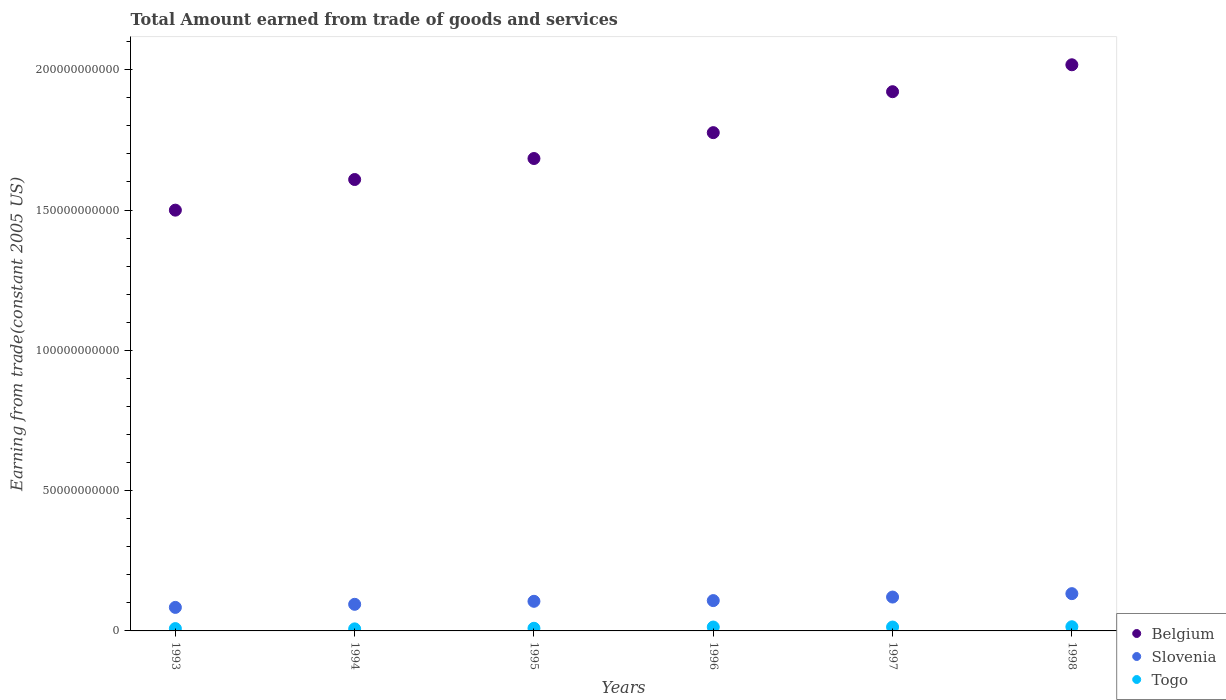What is the total amount earned by trading goods and services in Slovenia in 1996?
Your answer should be compact. 1.08e+1. Across all years, what is the maximum total amount earned by trading goods and services in Togo?
Provide a succinct answer. 1.49e+09. Across all years, what is the minimum total amount earned by trading goods and services in Belgium?
Offer a very short reply. 1.50e+11. What is the total total amount earned by trading goods and services in Togo in the graph?
Your response must be concise. 6.76e+09. What is the difference between the total amount earned by trading goods and services in Slovenia in 1993 and that in 1995?
Give a very brief answer. -2.17e+09. What is the difference between the total amount earned by trading goods and services in Slovenia in 1994 and the total amount earned by trading goods and services in Togo in 1996?
Offer a terse response. 8.10e+09. What is the average total amount earned by trading goods and services in Belgium per year?
Your answer should be very brief. 1.75e+11. In the year 1994, what is the difference between the total amount earned by trading goods and services in Belgium and total amount earned by trading goods and services in Slovenia?
Your answer should be very brief. 1.51e+11. In how many years, is the total amount earned by trading goods and services in Belgium greater than 100000000000 US$?
Offer a very short reply. 6. What is the ratio of the total amount earned by trading goods and services in Belgium in 1994 to that in 1997?
Your response must be concise. 0.84. Is the total amount earned by trading goods and services in Togo in 1996 less than that in 1998?
Your answer should be very brief. Yes. What is the difference between the highest and the second highest total amount earned by trading goods and services in Togo?
Your answer should be very brief. 1.02e+08. What is the difference between the highest and the lowest total amount earned by trading goods and services in Slovenia?
Your answer should be very brief. 4.90e+09. In how many years, is the total amount earned by trading goods and services in Togo greater than the average total amount earned by trading goods and services in Togo taken over all years?
Your response must be concise. 3. Is it the case that in every year, the sum of the total amount earned by trading goods and services in Slovenia and total amount earned by trading goods and services in Belgium  is greater than the total amount earned by trading goods and services in Togo?
Provide a succinct answer. Yes. Is the total amount earned by trading goods and services in Belgium strictly greater than the total amount earned by trading goods and services in Togo over the years?
Your response must be concise. Yes. How many years are there in the graph?
Your response must be concise. 6. What is the difference between two consecutive major ticks on the Y-axis?
Offer a very short reply. 5.00e+1. Are the values on the major ticks of Y-axis written in scientific E-notation?
Your answer should be compact. No. Does the graph contain any zero values?
Offer a terse response. No. Does the graph contain grids?
Make the answer very short. No. Where does the legend appear in the graph?
Ensure brevity in your answer.  Bottom right. How many legend labels are there?
Offer a terse response. 3. How are the legend labels stacked?
Ensure brevity in your answer.  Vertical. What is the title of the graph?
Offer a very short reply. Total Amount earned from trade of goods and services. What is the label or title of the X-axis?
Provide a short and direct response. Years. What is the label or title of the Y-axis?
Give a very brief answer. Earning from trade(constant 2005 US). What is the Earning from trade(constant 2005 US) in Belgium in 1993?
Your answer should be compact. 1.50e+11. What is the Earning from trade(constant 2005 US) in Slovenia in 1993?
Your answer should be compact. 8.38e+09. What is the Earning from trade(constant 2005 US) of Togo in 1993?
Offer a terse response. 8.31e+08. What is the Earning from trade(constant 2005 US) of Belgium in 1994?
Your answer should be very brief. 1.61e+11. What is the Earning from trade(constant 2005 US) of Slovenia in 1994?
Provide a succinct answer. 9.48e+09. What is the Earning from trade(constant 2005 US) of Togo in 1994?
Your response must be concise. 7.29e+08. What is the Earning from trade(constant 2005 US) in Belgium in 1995?
Your answer should be compact. 1.68e+11. What is the Earning from trade(constant 2005 US) of Slovenia in 1995?
Ensure brevity in your answer.  1.06e+1. What is the Earning from trade(constant 2005 US) in Togo in 1995?
Your answer should be compact. 9.46e+08. What is the Earning from trade(constant 2005 US) in Belgium in 1996?
Offer a terse response. 1.78e+11. What is the Earning from trade(constant 2005 US) in Slovenia in 1996?
Your answer should be compact. 1.08e+1. What is the Earning from trade(constant 2005 US) of Togo in 1996?
Your answer should be very brief. 1.38e+09. What is the Earning from trade(constant 2005 US) of Belgium in 1997?
Provide a succinct answer. 1.92e+11. What is the Earning from trade(constant 2005 US) in Slovenia in 1997?
Your response must be concise. 1.21e+1. What is the Earning from trade(constant 2005 US) in Togo in 1997?
Your answer should be very brief. 1.38e+09. What is the Earning from trade(constant 2005 US) of Belgium in 1998?
Keep it short and to the point. 2.02e+11. What is the Earning from trade(constant 2005 US) of Slovenia in 1998?
Offer a very short reply. 1.33e+1. What is the Earning from trade(constant 2005 US) of Togo in 1998?
Keep it short and to the point. 1.49e+09. Across all years, what is the maximum Earning from trade(constant 2005 US) of Belgium?
Provide a short and direct response. 2.02e+11. Across all years, what is the maximum Earning from trade(constant 2005 US) in Slovenia?
Offer a very short reply. 1.33e+1. Across all years, what is the maximum Earning from trade(constant 2005 US) in Togo?
Make the answer very short. 1.49e+09. Across all years, what is the minimum Earning from trade(constant 2005 US) of Belgium?
Provide a short and direct response. 1.50e+11. Across all years, what is the minimum Earning from trade(constant 2005 US) in Slovenia?
Your response must be concise. 8.38e+09. Across all years, what is the minimum Earning from trade(constant 2005 US) in Togo?
Offer a very short reply. 7.29e+08. What is the total Earning from trade(constant 2005 US) of Belgium in the graph?
Make the answer very short. 1.05e+12. What is the total Earning from trade(constant 2005 US) of Slovenia in the graph?
Ensure brevity in your answer.  6.46e+1. What is the total Earning from trade(constant 2005 US) of Togo in the graph?
Your answer should be very brief. 6.76e+09. What is the difference between the Earning from trade(constant 2005 US) of Belgium in 1993 and that in 1994?
Your response must be concise. -1.09e+1. What is the difference between the Earning from trade(constant 2005 US) in Slovenia in 1993 and that in 1994?
Your response must be concise. -1.10e+09. What is the difference between the Earning from trade(constant 2005 US) of Togo in 1993 and that in 1994?
Your response must be concise. 1.01e+08. What is the difference between the Earning from trade(constant 2005 US) of Belgium in 1993 and that in 1995?
Your answer should be very brief. -1.84e+1. What is the difference between the Earning from trade(constant 2005 US) of Slovenia in 1993 and that in 1995?
Keep it short and to the point. -2.17e+09. What is the difference between the Earning from trade(constant 2005 US) of Togo in 1993 and that in 1995?
Your answer should be compact. -1.15e+08. What is the difference between the Earning from trade(constant 2005 US) of Belgium in 1993 and that in 1996?
Your response must be concise. -2.76e+1. What is the difference between the Earning from trade(constant 2005 US) in Slovenia in 1993 and that in 1996?
Ensure brevity in your answer.  -2.43e+09. What is the difference between the Earning from trade(constant 2005 US) in Togo in 1993 and that in 1996?
Give a very brief answer. -5.54e+08. What is the difference between the Earning from trade(constant 2005 US) in Belgium in 1993 and that in 1997?
Your answer should be compact. -4.22e+1. What is the difference between the Earning from trade(constant 2005 US) in Slovenia in 1993 and that in 1997?
Your answer should be very brief. -3.69e+09. What is the difference between the Earning from trade(constant 2005 US) of Togo in 1993 and that in 1997?
Provide a short and direct response. -5.54e+08. What is the difference between the Earning from trade(constant 2005 US) of Belgium in 1993 and that in 1998?
Provide a succinct answer. -5.18e+1. What is the difference between the Earning from trade(constant 2005 US) of Slovenia in 1993 and that in 1998?
Give a very brief answer. -4.90e+09. What is the difference between the Earning from trade(constant 2005 US) in Togo in 1993 and that in 1998?
Give a very brief answer. -6.57e+08. What is the difference between the Earning from trade(constant 2005 US) of Belgium in 1994 and that in 1995?
Keep it short and to the point. -7.48e+09. What is the difference between the Earning from trade(constant 2005 US) in Slovenia in 1994 and that in 1995?
Provide a succinct answer. -1.07e+09. What is the difference between the Earning from trade(constant 2005 US) of Togo in 1994 and that in 1995?
Ensure brevity in your answer.  -2.17e+08. What is the difference between the Earning from trade(constant 2005 US) in Belgium in 1994 and that in 1996?
Provide a short and direct response. -1.67e+1. What is the difference between the Earning from trade(constant 2005 US) in Slovenia in 1994 and that in 1996?
Provide a succinct answer. -1.32e+09. What is the difference between the Earning from trade(constant 2005 US) in Togo in 1994 and that in 1996?
Provide a short and direct response. -6.55e+08. What is the difference between the Earning from trade(constant 2005 US) of Belgium in 1994 and that in 1997?
Your answer should be compact. -3.13e+1. What is the difference between the Earning from trade(constant 2005 US) of Slovenia in 1994 and that in 1997?
Ensure brevity in your answer.  -2.59e+09. What is the difference between the Earning from trade(constant 2005 US) in Togo in 1994 and that in 1997?
Provide a short and direct response. -6.55e+08. What is the difference between the Earning from trade(constant 2005 US) in Belgium in 1994 and that in 1998?
Give a very brief answer. -4.09e+1. What is the difference between the Earning from trade(constant 2005 US) in Slovenia in 1994 and that in 1998?
Offer a very short reply. -3.80e+09. What is the difference between the Earning from trade(constant 2005 US) in Togo in 1994 and that in 1998?
Make the answer very short. -7.58e+08. What is the difference between the Earning from trade(constant 2005 US) of Belgium in 1995 and that in 1996?
Your answer should be compact. -9.22e+09. What is the difference between the Earning from trade(constant 2005 US) of Slovenia in 1995 and that in 1996?
Make the answer very short. -2.53e+08. What is the difference between the Earning from trade(constant 2005 US) of Togo in 1995 and that in 1996?
Keep it short and to the point. -4.39e+08. What is the difference between the Earning from trade(constant 2005 US) in Belgium in 1995 and that in 1997?
Give a very brief answer. -2.38e+1. What is the difference between the Earning from trade(constant 2005 US) of Slovenia in 1995 and that in 1997?
Give a very brief answer. -1.52e+09. What is the difference between the Earning from trade(constant 2005 US) of Togo in 1995 and that in 1997?
Ensure brevity in your answer.  -4.39e+08. What is the difference between the Earning from trade(constant 2005 US) in Belgium in 1995 and that in 1998?
Offer a terse response. -3.34e+1. What is the difference between the Earning from trade(constant 2005 US) of Slovenia in 1995 and that in 1998?
Keep it short and to the point. -2.73e+09. What is the difference between the Earning from trade(constant 2005 US) of Togo in 1995 and that in 1998?
Give a very brief answer. -5.41e+08. What is the difference between the Earning from trade(constant 2005 US) in Belgium in 1996 and that in 1997?
Ensure brevity in your answer.  -1.46e+1. What is the difference between the Earning from trade(constant 2005 US) in Slovenia in 1996 and that in 1997?
Your answer should be compact. -1.26e+09. What is the difference between the Earning from trade(constant 2005 US) of Togo in 1996 and that in 1997?
Your answer should be very brief. 0. What is the difference between the Earning from trade(constant 2005 US) in Belgium in 1996 and that in 1998?
Ensure brevity in your answer.  -2.42e+1. What is the difference between the Earning from trade(constant 2005 US) of Slovenia in 1996 and that in 1998?
Keep it short and to the point. -2.48e+09. What is the difference between the Earning from trade(constant 2005 US) in Togo in 1996 and that in 1998?
Make the answer very short. -1.02e+08. What is the difference between the Earning from trade(constant 2005 US) of Belgium in 1997 and that in 1998?
Provide a succinct answer. -9.60e+09. What is the difference between the Earning from trade(constant 2005 US) of Slovenia in 1997 and that in 1998?
Make the answer very short. -1.21e+09. What is the difference between the Earning from trade(constant 2005 US) of Togo in 1997 and that in 1998?
Your answer should be very brief. -1.02e+08. What is the difference between the Earning from trade(constant 2005 US) in Belgium in 1993 and the Earning from trade(constant 2005 US) in Slovenia in 1994?
Your response must be concise. 1.40e+11. What is the difference between the Earning from trade(constant 2005 US) of Belgium in 1993 and the Earning from trade(constant 2005 US) of Togo in 1994?
Give a very brief answer. 1.49e+11. What is the difference between the Earning from trade(constant 2005 US) of Slovenia in 1993 and the Earning from trade(constant 2005 US) of Togo in 1994?
Ensure brevity in your answer.  7.65e+09. What is the difference between the Earning from trade(constant 2005 US) of Belgium in 1993 and the Earning from trade(constant 2005 US) of Slovenia in 1995?
Ensure brevity in your answer.  1.39e+11. What is the difference between the Earning from trade(constant 2005 US) in Belgium in 1993 and the Earning from trade(constant 2005 US) in Togo in 1995?
Give a very brief answer. 1.49e+11. What is the difference between the Earning from trade(constant 2005 US) in Slovenia in 1993 and the Earning from trade(constant 2005 US) in Togo in 1995?
Your response must be concise. 7.44e+09. What is the difference between the Earning from trade(constant 2005 US) of Belgium in 1993 and the Earning from trade(constant 2005 US) of Slovenia in 1996?
Ensure brevity in your answer.  1.39e+11. What is the difference between the Earning from trade(constant 2005 US) in Belgium in 1993 and the Earning from trade(constant 2005 US) in Togo in 1996?
Your answer should be very brief. 1.49e+11. What is the difference between the Earning from trade(constant 2005 US) of Slovenia in 1993 and the Earning from trade(constant 2005 US) of Togo in 1996?
Your answer should be very brief. 7.00e+09. What is the difference between the Earning from trade(constant 2005 US) in Belgium in 1993 and the Earning from trade(constant 2005 US) in Slovenia in 1997?
Offer a terse response. 1.38e+11. What is the difference between the Earning from trade(constant 2005 US) of Belgium in 1993 and the Earning from trade(constant 2005 US) of Togo in 1997?
Your response must be concise. 1.49e+11. What is the difference between the Earning from trade(constant 2005 US) of Slovenia in 1993 and the Earning from trade(constant 2005 US) of Togo in 1997?
Ensure brevity in your answer.  7.00e+09. What is the difference between the Earning from trade(constant 2005 US) in Belgium in 1993 and the Earning from trade(constant 2005 US) in Slovenia in 1998?
Provide a succinct answer. 1.37e+11. What is the difference between the Earning from trade(constant 2005 US) in Belgium in 1993 and the Earning from trade(constant 2005 US) in Togo in 1998?
Your answer should be very brief. 1.48e+11. What is the difference between the Earning from trade(constant 2005 US) of Slovenia in 1993 and the Earning from trade(constant 2005 US) of Togo in 1998?
Your answer should be very brief. 6.89e+09. What is the difference between the Earning from trade(constant 2005 US) of Belgium in 1994 and the Earning from trade(constant 2005 US) of Slovenia in 1995?
Give a very brief answer. 1.50e+11. What is the difference between the Earning from trade(constant 2005 US) in Belgium in 1994 and the Earning from trade(constant 2005 US) in Togo in 1995?
Provide a succinct answer. 1.60e+11. What is the difference between the Earning from trade(constant 2005 US) of Slovenia in 1994 and the Earning from trade(constant 2005 US) of Togo in 1995?
Keep it short and to the point. 8.54e+09. What is the difference between the Earning from trade(constant 2005 US) in Belgium in 1994 and the Earning from trade(constant 2005 US) in Slovenia in 1996?
Offer a terse response. 1.50e+11. What is the difference between the Earning from trade(constant 2005 US) in Belgium in 1994 and the Earning from trade(constant 2005 US) in Togo in 1996?
Offer a very short reply. 1.59e+11. What is the difference between the Earning from trade(constant 2005 US) of Slovenia in 1994 and the Earning from trade(constant 2005 US) of Togo in 1996?
Provide a short and direct response. 8.10e+09. What is the difference between the Earning from trade(constant 2005 US) in Belgium in 1994 and the Earning from trade(constant 2005 US) in Slovenia in 1997?
Your response must be concise. 1.49e+11. What is the difference between the Earning from trade(constant 2005 US) in Belgium in 1994 and the Earning from trade(constant 2005 US) in Togo in 1997?
Ensure brevity in your answer.  1.59e+11. What is the difference between the Earning from trade(constant 2005 US) in Slovenia in 1994 and the Earning from trade(constant 2005 US) in Togo in 1997?
Your answer should be compact. 8.10e+09. What is the difference between the Earning from trade(constant 2005 US) in Belgium in 1994 and the Earning from trade(constant 2005 US) in Slovenia in 1998?
Your answer should be compact. 1.48e+11. What is the difference between the Earning from trade(constant 2005 US) in Belgium in 1994 and the Earning from trade(constant 2005 US) in Togo in 1998?
Offer a very short reply. 1.59e+11. What is the difference between the Earning from trade(constant 2005 US) of Slovenia in 1994 and the Earning from trade(constant 2005 US) of Togo in 1998?
Make the answer very short. 8.00e+09. What is the difference between the Earning from trade(constant 2005 US) of Belgium in 1995 and the Earning from trade(constant 2005 US) of Slovenia in 1996?
Give a very brief answer. 1.58e+11. What is the difference between the Earning from trade(constant 2005 US) of Belgium in 1995 and the Earning from trade(constant 2005 US) of Togo in 1996?
Your response must be concise. 1.67e+11. What is the difference between the Earning from trade(constant 2005 US) of Slovenia in 1995 and the Earning from trade(constant 2005 US) of Togo in 1996?
Ensure brevity in your answer.  9.17e+09. What is the difference between the Earning from trade(constant 2005 US) in Belgium in 1995 and the Earning from trade(constant 2005 US) in Slovenia in 1997?
Give a very brief answer. 1.56e+11. What is the difference between the Earning from trade(constant 2005 US) in Belgium in 1995 and the Earning from trade(constant 2005 US) in Togo in 1997?
Provide a succinct answer. 1.67e+11. What is the difference between the Earning from trade(constant 2005 US) of Slovenia in 1995 and the Earning from trade(constant 2005 US) of Togo in 1997?
Your answer should be very brief. 9.17e+09. What is the difference between the Earning from trade(constant 2005 US) in Belgium in 1995 and the Earning from trade(constant 2005 US) in Slovenia in 1998?
Ensure brevity in your answer.  1.55e+11. What is the difference between the Earning from trade(constant 2005 US) of Belgium in 1995 and the Earning from trade(constant 2005 US) of Togo in 1998?
Your response must be concise. 1.67e+11. What is the difference between the Earning from trade(constant 2005 US) in Slovenia in 1995 and the Earning from trade(constant 2005 US) in Togo in 1998?
Your answer should be compact. 9.07e+09. What is the difference between the Earning from trade(constant 2005 US) of Belgium in 1996 and the Earning from trade(constant 2005 US) of Slovenia in 1997?
Give a very brief answer. 1.66e+11. What is the difference between the Earning from trade(constant 2005 US) in Belgium in 1996 and the Earning from trade(constant 2005 US) in Togo in 1997?
Make the answer very short. 1.76e+11. What is the difference between the Earning from trade(constant 2005 US) of Slovenia in 1996 and the Earning from trade(constant 2005 US) of Togo in 1997?
Offer a very short reply. 9.42e+09. What is the difference between the Earning from trade(constant 2005 US) of Belgium in 1996 and the Earning from trade(constant 2005 US) of Slovenia in 1998?
Your answer should be very brief. 1.64e+11. What is the difference between the Earning from trade(constant 2005 US) of Belgium in 1996 and the Earning from trade(constant 2005 US) of Togo in 1998?
Provide a succinct answer. 1.76e+11. What is the difference between the Earning from trade(constant 2005 US) in Slovenia in 1996 and the Earning from trade(constant 2005 US) in Togo in 1998?
Give a very brief answer. 9.32e+09. What is the difference between the Earning from trade(constant 2005 US) in Belgium in 1997 and the Earning from trade(constant 2005 US) in Slovenia in 1998?
Provide a short and direct response. 1.79e+11. What is the difference between the Earning from trade(constant 2005 US) of Belgium in 1997 and the Earning from trade(constant 2005 US) of Togo in 1998?
Your answer should be compact. 1.91e+11. What is the difference between the Earning from trade(constant 2005 US) in Slovenia in 1997 and the Earning from trade(constant 2005 US) in Togo in 1998?
Keep it short and to the point. 1.06e+1. What is the average Earning from trade(constant 2005 US) in Belgium per year?
Offer a very short reply. 1.75e+11. What is the average Earning from trade(constant 2005 US) of Slovenia per year?
Offer a terse response. 1.08e+1. What is the average Earning from trade(constant 2005 US) of Togo per year?
Provide a succinct answer. 1.13e+09. In the year 1993, what is the difference between the Earning from trade(constant 2005 US) in Belgium and Earning from trade(constant 2005 US) in Slovenia?
Your answer should be very brief. 1.42e+11. In the year 1993, what is the difference between the Earning from trade(constant 2005 US) of Belgium and Earning from trade(constant 2005 US) of Togo?
Ensure brevity in your answer.  1.49e+11. In the year 1993, what is the difference between the Earning from trade(constant 2005 US) of Slovenia and Earning from trade(constant 2005 US) of Togo?
Offer a terse response. 7.55e+09. In the year 1994, what is the difference between the Earning from trade(constant 2005 US) in Belgium and Earning from trade(constant 2005 US) in Slovenia?
Ensure brevity in your answer.  1.51e+11. In the year 1994, what is the difference between the Earning from trade(constant 2005 US) in Belgium and Earning from trade(constant 2005 US) in Togo?
Offer a terse response. 1.60e+11. In the year 1994, what is the difference between the Earning from trade(constant 2005 US) of Slovenia and Earning from trade(constant 2005 US) of Togo?
Keep it short and to the point. 8.75e+09. In the year 1995, what is the difference between the Earning from trade(constant 2005 US) of Belgium and Earning from trade(constant 2005 US) of Slovenia?
Make the answer very short. 1.58e+11. In the year 1995, what is the difference between the Earning from trade(constant 2005 US) in Belgium and Earning from trade(constant 2005 US) in Togo?
Your response must be concise. 1.67e+11. In the year 1995, what is the difference between the Earning from trade(constant 2005 US) in Slovenia and Earning from trade(constant 2005 US) in Togo?
Offer a very short reply. 9.61e+09. In the year 1996, what is the difference between the Earning from trade(constant 2005 US) in Belgium and Earning from trade(constant 2005 US) in Slovenia?
Provide a short and direct response. 1.67e+11. In the year 1996, what is the difference between the Earning from trade(constant 2005 US) of Belgium and Earning from trade(constant 2005 US) of Togo?
Offer a terse response. 1.76e+11. In the year 1996, what is the difference between the Earning from trade(constant 2005 US) of Slovenia and Earning from trade(constant 2005 US) of Togo?
Offer a terse response. 9.42e+09. In the year 1997, what is the difference between the Earning from trade(constant 2005 US) in Belgium and Earning from trade(constant 2005 US) in Slovenia?
Provide a succinct answer. 1.80e+11. In the year 1997, what is the difference between the Earning from trade(constant 2005 US) of Belgium and Earning from trade(constant 2005 US) of Togo?
Your answer should be very brief. 1.91e+11. In the year 1997, what is the difference between the Earning from trade(constant 2005 US) in Slovenia and Earning from trade(constant 2005 US) in Togo?
Provide a short and direct response. 1.07e+1. In the year 1998, what is the difference between the Earning from trade(constant 2005 US) in Belgium and Earning from trade(constant 2005 US) in Slovenia?
Provide a succinct answer. 1.88e+11. In the year 1998, what is the difference between the Earning from trade(constant 2005 US) in Belgium and Earning from trade(constant 2005 US) in Togo?
Your answer should be very brief. 2.00e+11. In the year 1998, what is the difference between the Earning from trade(constant 2005 US) in Slovenia and Earning from trade(constant 2005 US) in Togo?
Provide a short and direct response. 1.18e+1. What is the ratio of the Earning from trade(constant 2005 US) of Belgium in 1993 to that in 1994?
Your response must be concise. 0.93. What is the ratio of the Earning from trade(constant 2005 US) of Slovenia in 1993 to that in 1994?
Offer a terse response. 0.88. What is the ratio of the Earning from trade(constant 2005 US) in Togo in 1993 to that in 1994?
Your answer should be compact. 1.14. What is the ratio of the Earning from trade(constant 2005 US) in Belgium in 1993 to that in 1995?
Provide a succinct answer. 0.89. What is the ratio of the Earning from trade(constant 2005 US) in Slovenia in 1993 to that in 1995?
Offer a very short reply. 0.79. What is the ratio of the Earning from trade(constant 2005 US) of Togo in 1993 to that in 1995?
Provide a succinct answer. 0.88. What is the ratio of the Earning from trade(constant 2005 US) in Belgium in 1993 to that in 1996?
Offer a very short reply. 0.84. What is the ratio of the Earning from trade(constant 2005 US) in Slovenia in 1993 to that in 1996?
Give a very brief answer. 0.78. What is the ratio of the Earning from trade(constant 2005 US) of Togo in 1993 to that in 1996?
Offer a terse response. 0.6. What is the ratio of the Earning from trade(constant 2005 US) of Belgium in 1993 to that in 1997?
Keep it short and to the point. 0.78. What is the ratio of the Earning from trade(constant 2005 US) of Slovenia in 1993 to that in 1997?
Your response must be concise. 0.69. What is the ratio of the Earning from trade(constant 2005 US) in Togo in 1993 to that in 1997?
Keep it short and to the point. 0.6. What is the ratio of the Earning from trade(constant 2005 US) in Belgium in 1993 to that in 1998?
Provide a short and direct response. 0.74. What is the ratio of the Earning from trade(constant 2005 US) of Slovenia in 1993 to that in 1998?
Offer a very short reply. 0.63. What is the ratio of the Earning from trade(constant 2005 US) of Togo in 1993 to that in 1998?
Provide a succinct answer. 0.56. What is the ratio of the Earning from trade(constant 2005 US) in Belgium in 1994 to that in 1995?
Provide a short and direct response. 0.96. What is the ratio of the Earning from trade(constant 2005 US) of Slovenia in 1994 to that in 1995?
Provide a succinct answer. 0.9. What is the ratio of the Earning from trade(constant 2005 US) in Togo in 1994 to that in 1995?
Your answer should be compact. 0.77. What is the ratio of the Earning from trade(constant 2005 US) in Belgium in 1994 to that in 1996?
Your answer should be very brief. 0.91. What is the ratio of the Earning from trade(constant 2005 US) in Slovenia in 1994 to that in 1996?
Your response must be concise. 0.88. What is the ratio of the Earning from trade(constant 2005 US) in Togo in 1994 to that in 1996?
Your answer should be compact. 0.53. What is the ratio of the Earning from trade(constant 2005 US) in Belgium in 1994 to that in 1997?
Provide a succinct answer. 0.84. What is the ratio of the Earning from trade(constant 2005 US) of Slovenia in 1994 to that in 1997?
Ensure brevity in your answer.  0.79. What is the ratio of the Earning from trade(constant 2005 US) of Togo in 1994 to that in 1997?
Your response must be concise. 0.53. What is the ratio of the Earning from trade(constant 2005 US) of Belgium in 1994 to that in 1998?
Provide a short and direct response. 0.8. What is the ratio of the Earning from trade(constant 2005 US) of Slovenia in 1994 to that in 1998?
Provide a succinct answer. 0.71. What is the ratio of the Earning from trade(constant 2005 US) in Togo in 1994 to that in 1998?
Your answer should be compact. 0.49. What is the ratio of the Earning from trade(constant 2005 US) of Belgium in 1995 to that in 1996?
Make the answer very short. 0.95. What is the ratio of the Earning from trade(constant 2005 US) of Slovenia in 1995 to that in 1996?
Keep it short and to the point. 0.98. What is the ratio of the Earning from trade(constant 2005 US) in Togo in 1995 to that in 1996?
Your answer should be compact. 0.68. What is the ratio of the Earning from trade(constant 2005 US) in Belgium in 1995 to that in 1997?
Offer a very short reply. 0.88. What is the ratio of the Earning from trade(constant 2005 US) of Slovenia in 1995 to that in 1997?
Provide a succinct answer. 0.87. What is the ratio of the Earning from trade(constant 2005 US) of Togo in 1995 to that in 1997?
Ensure brevity in your answer.  0.68. What is the ratio of the Earning from trade(constant 2005 US) in Belgium in 1995 to that in 1998?
Make the answer very short. 0.83. What is the ratio of the Earning from trade(constant 2005 US) in Slovenia in 1995 to that in 1998?
Your answer should be compact. 0.79. What is the ratio of the Earning from trade(constant 2005 US) in Togo in 1995 to that in 1998?
Your response must be concise. 0.64. What is the ratio of the Earning from trade(constant 2005 US) in Belgium in 1996 to that in 1997?
Your response must be concise. 0.92. What is the ratio of the Earning from trade(constant 2005 US) in Slovenia in 1996 to that in 1997?
Your answer should be very brief. 0.9. What is the ratio of the Earning from trade(constant 2005 US) in Togo in 1996 to that in 1997?
Offer a very short reply. 1. What is the ratio of the Earning from trade(constant 2005 US) in Belgium in 1996 to that in 1998?
Make the answer very short. 0.88. What is the ratio of the Earning from trade(constant 2005 US) of Slovenia in 1996 to that in 1998?
Your answer should be very brief. 0.81. What is the ratio of the Earning from trade(constant 2005 US) in Togo in 1996 to that in 1998?
Your answer should be compact. 0.93. What is the ratio of the Earning from trade(constant 2005 US) in Belgium in 1997 to that in 1998?
Give a very brief answer. 0.95. What is the ratio of the Earning from trade(constant 2005 US) in Slovenia in 1997 to that in 1998?
Make the answer very short. 0.91. What is the ratio of the Earning from trade(constant 2005 US) of Togo in 1997 to that in 1998?
Provide a short and direct response. 0.93. What is the difference between the highest and the second highest Earning from trade(constant 2005 US) of Belgium?
Ensure brevity in your answer.  9.60e+09. What is the difference between the highest and the second highest Earning from trade(constant 2005 US) of Slovenia?
Provide a short and direct response. 1.21e+09. What is the difference between the highest and the second highest Earning from trade(constant 2005 US) of Togo?
Provide a succinct answer. 1.02e+08. What is the difference between the highest and the lowest Earning from trade(constant 2005 US) in Belgium?
Your answer should be very brief. 5.18e+1. What is the difference between the highest and the lowest Earning from trade(constant 2005 US) of Slovenia?
Ensure brevity in your answer.  4.90e+09. What is the difference between the highest and the lowest Earning from trade(constant 2005 US) in Togo?
Your answer should be very brief. 7.58e+08. 